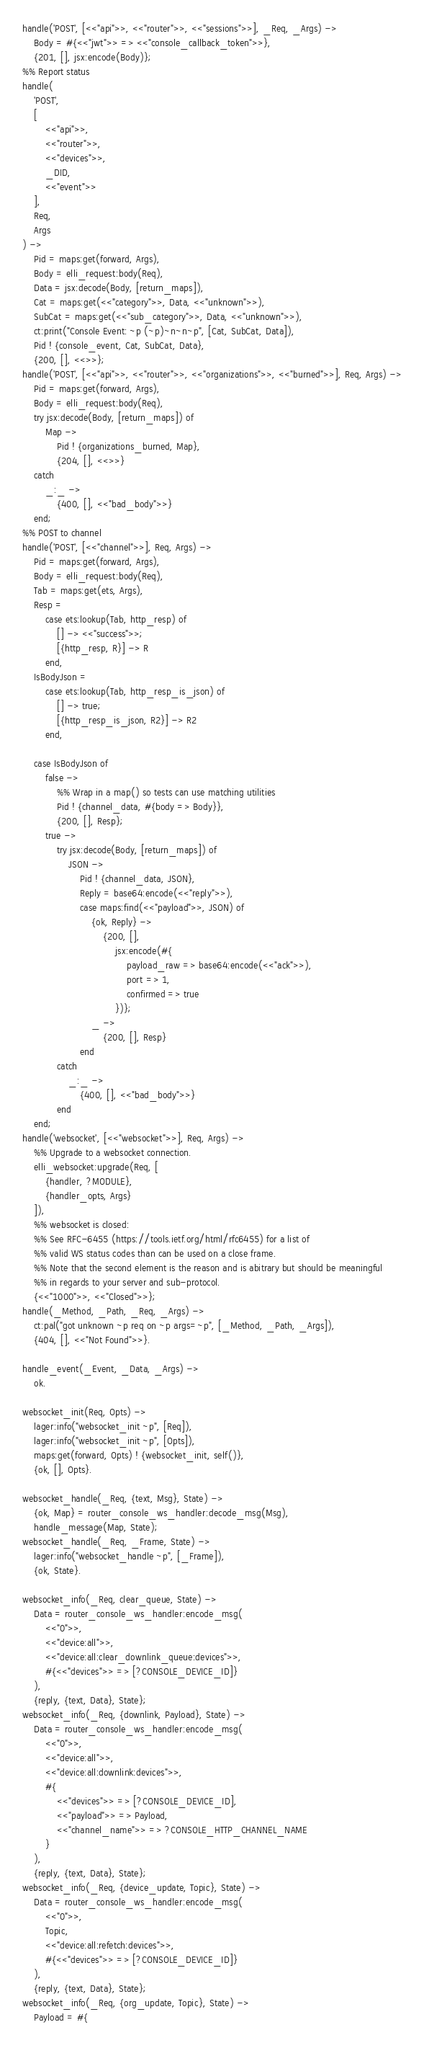<code> <loc_0><loc_0><loc_500><loc_500><_Erlang_>handle('POST', [<<"api">>, <<"router">>, <<"sessions">>], _Req, _Args) ->
    Body = #{<<"jwt">> => <<"console_callback_token">>},
    {201, [], jsx:encode(Body)};
%% Report status
handle(
    'POST',
    [
        <<"api">>,
        <<"router">>,
        <<"devices">>,
        _DID,
        <<"event">>
    ],
    Req,
    Args
) ->
    Pid = maps:get(forward, Args),
    Body = elli_request:body(Req),
    Data = jsx:decode(Body, [return_maps]),
    Cat = maps:get(<<"category">>, Data, <<"unknown">>),
    SubCat = maps:get(<<"sub_category">>, Data, <<"unknown">>),
    ct:print("Console Event: ~p (~p)~n~n~p", [Cat, SubCat, Data]),
    Pid ! {console_event, Cat, SubCat, Data},
    {200, [], <<>>};
handle('POST', [<<"api">>, <<"router">>, <<"organizations">>, <<"burned">>], Req, Args) ->
    Pid = maps:get(forward, Args),
    Body = elli_request:body(Req),
    try jsx:decode(Body, [return_maps]) of
        Map ->
            Pid ! {organizations_burned, Map},
            {204, [], <<>>}
    catch
        _:_ ->
            {400, [], <<"bad_body">>}
    end;
%% POST to channel
handle('POST', [<<"channel">>], Req, Args) ->
    Pid = maps:get(forward, Args),
    Body = elli_request:body(Req),
    Tab = maps:get(ets, Args),
    Resp =
        case ets:lookup(Tab, http_resp) of
            [] -> <<"success">>;
            [{http_resp, R}] -> R
        end,
    IsBodyJson =
        case ets:lookup(Tab, http_resp_is_json) of
            [] -> true;
            [{http_resp_is_json, R2}] -> R2
        end,

    case IsBodyJson of
        false ->
            %% Wrap in a map() so tests can use matching utilities
            Pid ! {channel_data, #{body => Body}},
            {200, [], Resp};
        true ->
            try jsx:decode(Body, [return_maps]) of
                JSON ->
                    Pid ! {channel_data, JSON},
                    Reply = base64:encode(<<"reply">>),
                    case maps:find(<<"payload">>, JSON) of
                        {ok, Reply} ->
                            {200, [],
                                jsx:encode(#{
                                    payload_raw => base64:encode(<<"ack">>),
                                    port => 1,
                                    confirmed => true
                                })};
                        _ ->
                            {200, [], Resp}
                    end
            catch
                _:_ ->
                    {400, [], <<"bad_body">>}
            end
    end;
handle('websocket', [<<"websocket">>], Req, Args) ->
    %% Upgrade to a websocket connection.
    elli_websocket:upgrade(Req, [
        {handler, ?MODULE},
        {handler_opts, Args}
    ]),
    %% websocket is closed:
    %% See RFC-6455 (https://tools.ietf.org/html/rfc6455) for a list of
    %% valid WS status codes than can be used on a close frame.
    %% Note that the second element is the reason and is abitrary but should be meaningful
    %% in regards to your server and sub-protocol.
    {<<"1000">>, <<"Closed">>};
handle(_Method, _Path, _Req, _Args) ->
    ct:pal("got unknown ~p req on ~p args=~p", [_Method, _Path, _Args]),
    {404, [], <<"Not Found">>}.

handle_event(_Event, _Data, _Args) ->
    ok.

websocket_init(Req, Opts) ->
    lager:info("websocket_init ~p", [Req]),
    lager:info("websocket_init ~p", [Opts]),
    maps:get(forward, Opts) ! {websocket_init, self()},
    {ok, [], Opts}.

websocket_handle(_Req, {text, Msg}, State) ->
    {ok, Map} = router_console_ws_handler:decode_msg(Msg),
    handle_message(Map, State);
websocket_handle(_Req, _Frame, State) ->
    lager:info("websocket_handle ~p", [_Frame]),
    {ok, State}.

websocket_info(_Req, clear_queue, State) ->
    Data = router_console_ws_handler:encode_msg(
        <<"0">>,
        <<"device:all">>,
        <<"device:all:clear_downlink_queue:devices">>,
        #{<<"devices">> => [?CONSOLE_DEVICE_ID]}
    ),
    {reply, {text, Data}, State};
websocket_info(_Req, {downlink, Payload}, State) ->
    Data = router_console_ws_handler:encode_msg(
        <<"0">>,
        <<"device:all">>,
        <<"device:all:downlink:devices">>,
        #{
            <<"devices">> => [?CONSOLE_DEVICE_ID],
            <<"payload">> => Payload,
            <<"channel_name">> => ?CONSOLE_HTTP_CHANNEL_NAME
        }
    ),
    {reply, {text, Data}, State};
websocket_info(_Req, {device_update, Topic}, State) ->
    Data = router_console_ws_handler:encode_msg(
        <<"0">>,
        Topic,
        <<"device:all:refetch:devices">>,
        #{<<"devices">> => [?CONSOLE_DEVICE_ID]}
    ),
    {reply, {text, Data}, State};
websocket_info(_Req, {org_update, Topic}, State) ->
    Payload = #{</code> 